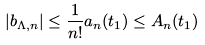Convert formula to latex. <formula><loc_0><loc_0><loc_500><loc_500>\left | b _ { \Lambda , n } \right | \leq \frac { 1 } { n ! } a _ { n } ( t _ { 1 } ) \leq A _ { n } ( t _ { 1 } )</formula> 